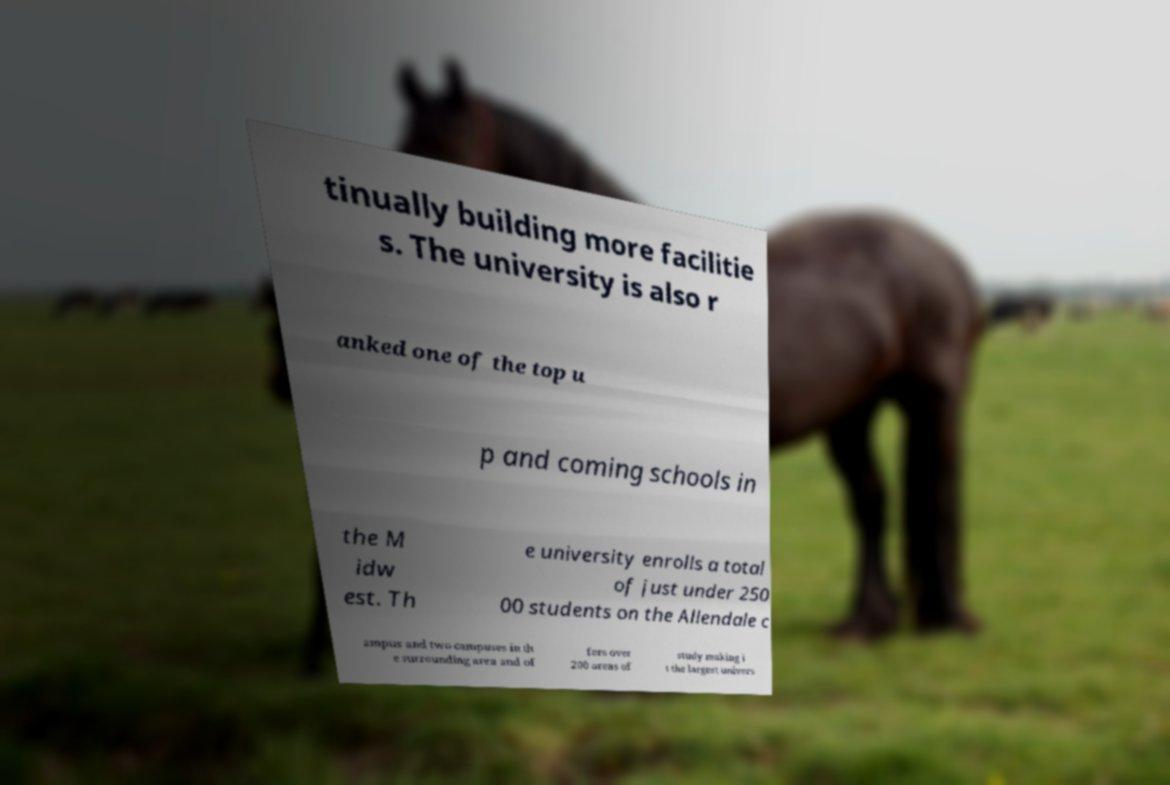Can you read and provide the text displayed in the image?This photo seems to have some interesting text. Can you extract and type it out for me? tinually building more facilitie s. The university is also r anked one of the top u p and coming schools in the M idw est. Th e university enrolls a total of just under 250 00 students on the Allendale c ampus and two campuses in th e surrounding area and of fers over 200 areas of study making i t the largest univers 